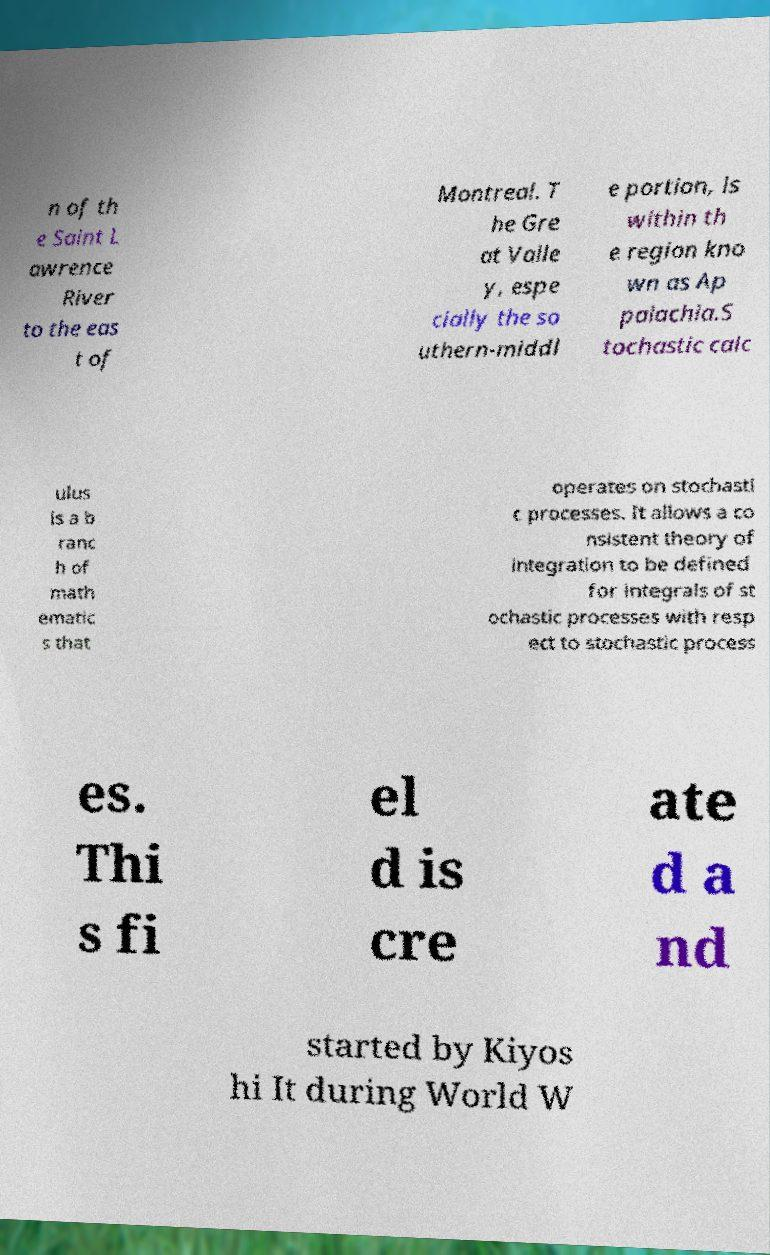There's text embedded in this image that I need extracted. Can you transcribe it verbatim? n of th e Saint L awrence River to the eas t of Montreal. T he Gre at Valle y, espe cially the so uthern-middl e portion, is within th e region kno wn as Ap palachia.S tochastic calc ulus is a b ranc h of math ematic s that operates on stochasti c processes. It allows a co nsistent theory of integration to be defined for integrals of st ochastic processes with resp ect to stochastic process es. Thi s fi el d is cre ate d a nd started by Kiyos hi It during World W 